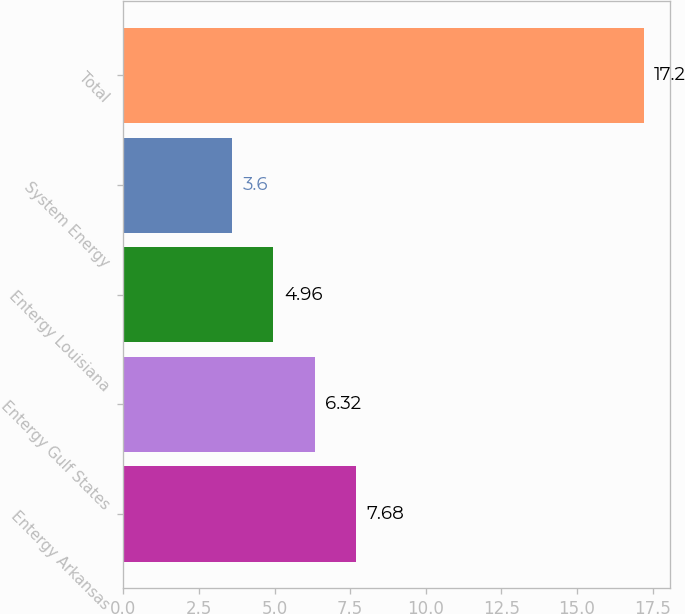<chart> <loc_0><loc_0><loc_500><loc_500><bar_chart><fcel>Entergy Arkansas<fcel>Entergy Gulf States<fcel>Entergy Louisiana<fcel>System Energy<fcel>Total<nl><fcel>7.68<fcel>6.32<fcel>4.96<fcel>3.6<fcel>17.2<nl></chart> 